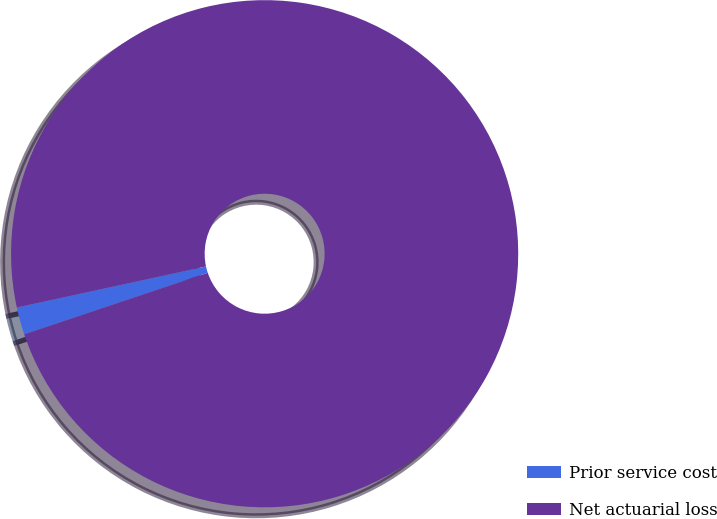<chart> <loc_0><loc_0><loc_500><loc_500><pie_chart><fcel>Prior service cost<fcel>Net actuarial loss<nl><fcel>1.75%<fcel>98.25%<nl></chart> 